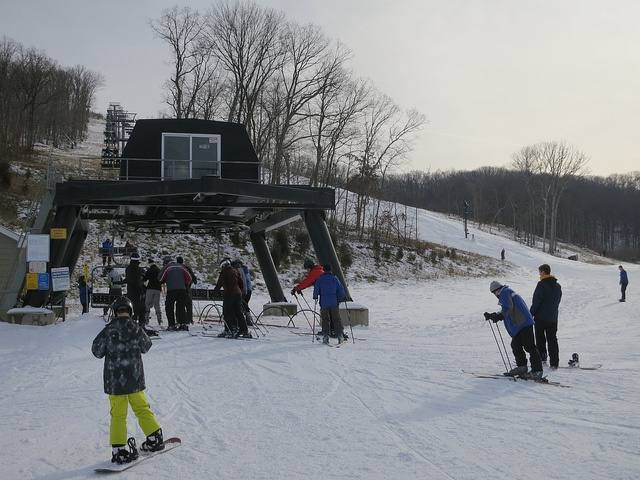Describe the objects in this image and their specific colors. I can see people in darkgray, black, olive, and gray tones, people in darkgray, black, navy, and gray tones, people in darkgray, black, gray, and maroon tones, people in darkgray, black, gray, and navy tones, and people in darkgray, black, gray, and maroon tones in this image. 